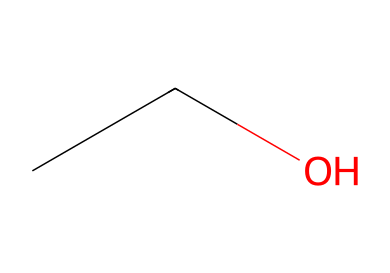What is the name of this chemical? The SMILES representation "CCO" corresponds to ethanol, which is a common name for the chemical with this structure. It consists of two carbon atoms and one hydroxyl group.
Answer: ethanol How many carbon atoms are in this molecule? By analyzing the SMILES "CCO," we see that there are two 'C' characters, indicating two carbon atoms present in the structure.
Answer: two How many hydrogen atoms are in this molecule? In ethanol, each carbon typically bonds with hydrogen atoms to complete its tetravalent nature. For two carbon atoms, there are six hydrogen atoms connected in total, leading to the formula C2H6O.
Answer: six What type of functional group is present in this molecule? The presence of an -OH group in the structure indicates that this compound has a hydroxyl functional group, characteristic of alcohols like ethanol.
Answer: hydroxyl Is this molecule classified as a simple carbohydrate? Ethanol (C2H5OH) is an alcohol and does not fit into the category of carbohydrates, which generally comprise sugars and their derivatives with a specific formula.
Answer: no What is the molecular formula of this compound? By interpreting the SMILES "CCO," we can count the atoms: 2 carbons, 6 hydrogens, and 1 oxygen, leading us to the molecular formula C2H6O.
Answer: C2H6O Is this compound polar or nonpolar? The presence of the hydroxyl functional group (-OH) indicates that ethanol is polar due to the electronegativity difference between oxygen and hydrogen, leading to a dipole moment.
Answer: polar 